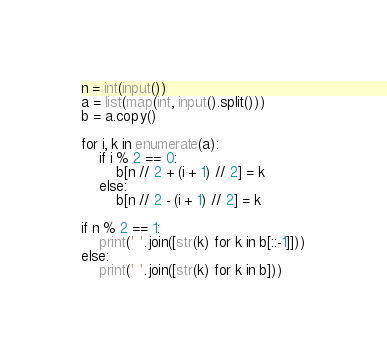Convert code to text. <code><loc_0><loc_0><loc_500><loc_500><_Python_>n = int(input())
a = list(map(int, input().split()))
b = a.copy()

for i, k in enumerate(a):
    if i % 2 == 0:
        b[n // 2 + (i + 1) // 2] = k
    else:
        b[n // 2 - (i + 1) // 2] = k

if n % 2 == 1:
    print(' '.join([str(k) for k in b[::-1]]))
else:
    print(' '.join([str(k) for k in b]))</code> 